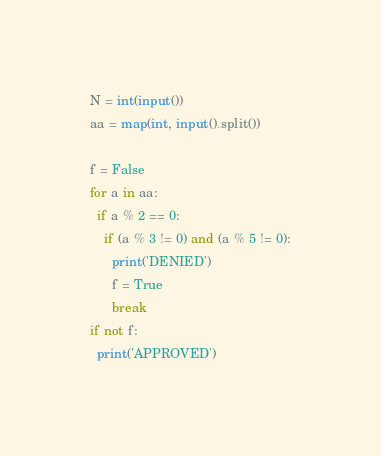Convert code to text. <code><loc_0><loc_0><loc_500><loc_500><_Python_>N = int(input())
aa = map(int, input().split())

f = False
for a in aa:
  if a % 2 == 0:
    if (a % 3 != 0) and (a % 5 != 0):
      print('DENIED')
      f = True
      break
if not f:
  print('APPROVED')</code> 